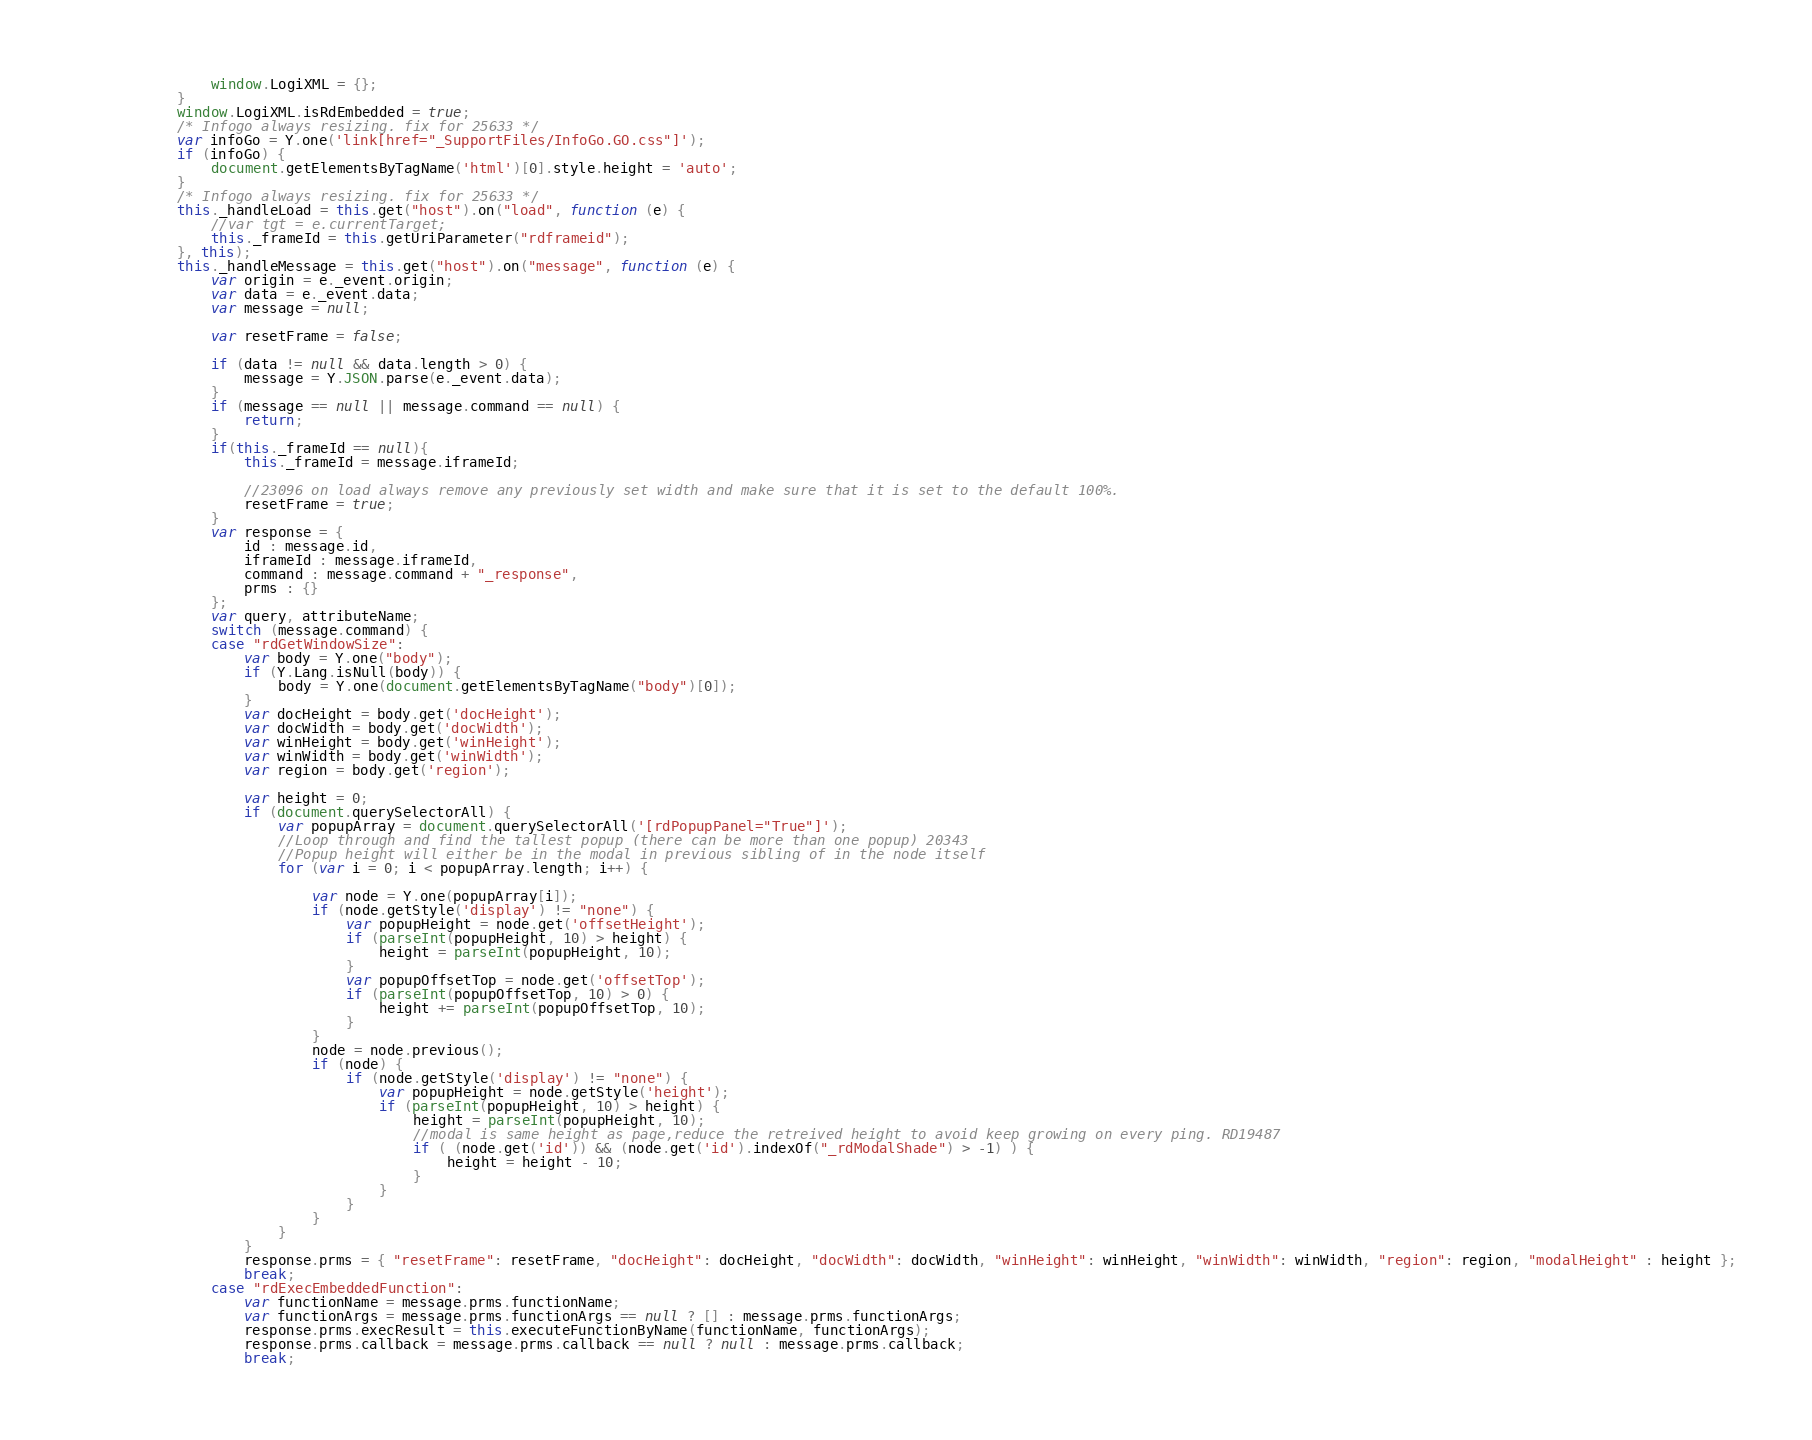Convert code to text. <code><loc_0><loc_0><loc_500><loc_500><_JavaScript_>                window.LogiXML = {};
            }
            window.LogiXML.isRdEmbedded = true;
            /* Infogo always resizing. fix for 25633 */
            var infoGo = Y.one('link[href="_SupportFiles/InfoGo.GO.css"]');
            if (infoGo) {
                document.getElementsByTagName('html')[0].style.height = 'auto';
            }
            /* Infogo always resizing. fix for 25633 */
            this._handleLoad = this.get("host").on("load", function (e) {
                //var tgt = e.currentTarget;
                this._frameId = this.getUriParameter("rdframeid");
            }, this);
            this._handleMessage = this.get("host").on("message", function (e) {
                var origin = e._event.origin;
                var data = e._event.data;
                var message = null;

                var resetFrame = false;

                if (data != null && data.length > 0) {
                    message = Y.JSON.parse(e._event.data);
                }
                if (message == null || message.command == null) {
                    return;
                }
				if(this._frameId == null){
				    this._frameId = message.iframeId;

                    //23096 on load always remove any previously set width and make sure that it is set to the default 100%.
				    resetFrame = true;
				}
                var response = {
					id : message.id,
					iframeId : message.iframeId,
					command : message.command + "_response",
					prms : {}
				};
				var query, attributeName;
                switch (message.command) {
				case "rdGetWindowSize":
				    var body = Y.one("body");
				    if (Y.Lang.isNull(body)) {
				        body = Y.one(document.getElementsByTagName("body")[0]);
				    }
				    var docHeight = body.get('docHeight');
				    var docWidth = body.get('docWidth');
				    var winHeight = body.get('winHeight');
				    var winWidth = body.get('winWidth');
				    var region = body.get('region');

				    var height = 0;
				    if (document.querySelectorAll) {
				        var popupArray = document.querySelectorAll('[rdPopupPanel="True"]'); 
				        //Loop through and find the tallest popup (there can be more than one popup) 20343
				        //Popup height will either be in the modal in previous sibling of in the node itself
				        for (var i = 0; i < popupArray.length; i++) {

				            var node = Y.one(popupArray[i]);
				            if (node.getStyle('display') != "none") {
				                var popupHeight = node.get('offsetHeight');
				                if (parseInt(popupHeight, 10) > height) {
				                    height = parseInt(popupHeight, 10);
				                }
				                var popupOffsetTop = node.get('offsetTop');
				                if (parseInt(popupOffsetTop, 10) > 0) {
				                    height += parseInt(popupOffsetTop, 10);
				                }
				            }
				            node = node.previous();
				            if (node) {
				                if (node.getStyle('display') != "none") {
				                    var popupHeight = node.getStyle('height');
				                    if (parseInt(popupHeight, 10) > height) {
				                        height = parseInt(popupHeight, 10);
				                        //modal is same height as page,reduce the retreived height to avoid keep growing on every ping. RD19487
				                        if ( (node.get('id')) && (node.get('id').indexOf("_rdModalShade") > -1) ) {
				                            height = height - 10;
				                        }				                        
				                    }
				                }
				            }
				        }
				    }
					response.prms = { "resetFrame": resetFrame, "docHeight": docHeight, "docWidth": docWidth, "winHeight": winHeight, "winWidth": winWidth, "region": region, "modalHeight" : height };
					break;
	            case "rdExecEmbeddedFunction":
					var functionName = message.prms.functionName;
					var functionArgs = message.prms.functionArgs == null ? [] : message.prms.functionArgs;
					response.prms.execResult = this.executeFunctionByName(functionName, functionArgs);
					response.prms.callback = message.prms.callback == null ? null : message.prms.callback;
					break;</code> 